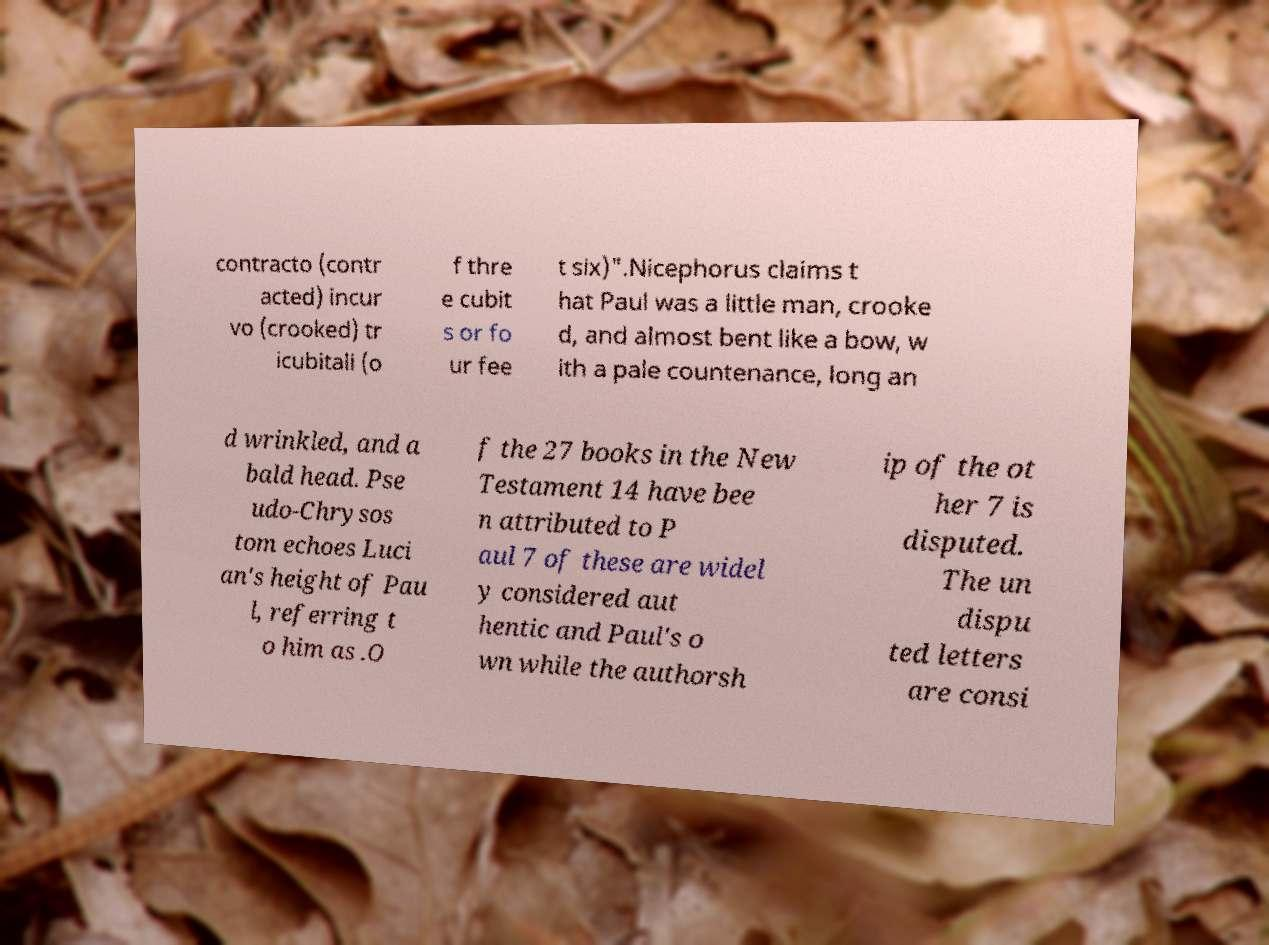For documentation purposes, I need the text within this image transcribed. Could you provide that? contracto (contr acted) incur vo (crooked) tr icubitali (o f thre e cubit s or fo ur fee t six)".Nicephorus claims t hat Paul was a little man, crooke d, and almost bent like a bow, w ith a pale countenance, long an d wrinkled, and a bald head. Pse udo-Chrysos tom echoes Luci an's height of Pau l, referring t o him as .O f the 27 books in the New Testament 14 have bee n attributed to P aul 7 of these are widel y considered aut hentic and Paul's o wn while the authorsh ip of the ot her 7 is disputed. The un dispu ted letters are consi 